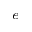Convert formula to latex. <formula><loc_0><loc_0><loc_500><loc_500>^ { e }</formula> 